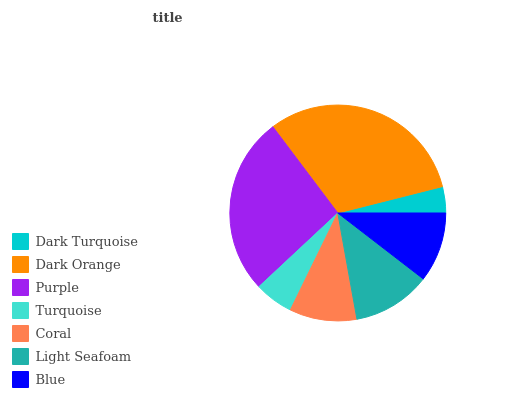Is Dark Turquoise the minimum?
Answer yes or no. Yes. Is Dark Orange the maximum?
Answer yes or no. Yes. Is Purple the minimum?
Answer yes or no. No. Is Purple the maximum?
Answer yes or no. No. Is Dark Orange greater than Purple?
Answer yes or no. Yes. Is Purple less than Dark Orange?
Answer yes or no. Yes. Is Purple greater than Dark Orange?
Answer yes or no. No. Is Dark Orange less than Purple?
Answer yes or no. No. Is Blue the high median?
Answer yes or no. Yes. Is Blue the low median?
Answer yes or no. Yes. Is Dark Turquoise the high median?
Answer yes or no. No. Is Light Seafoam the low median?
Answer yes or no. No. 